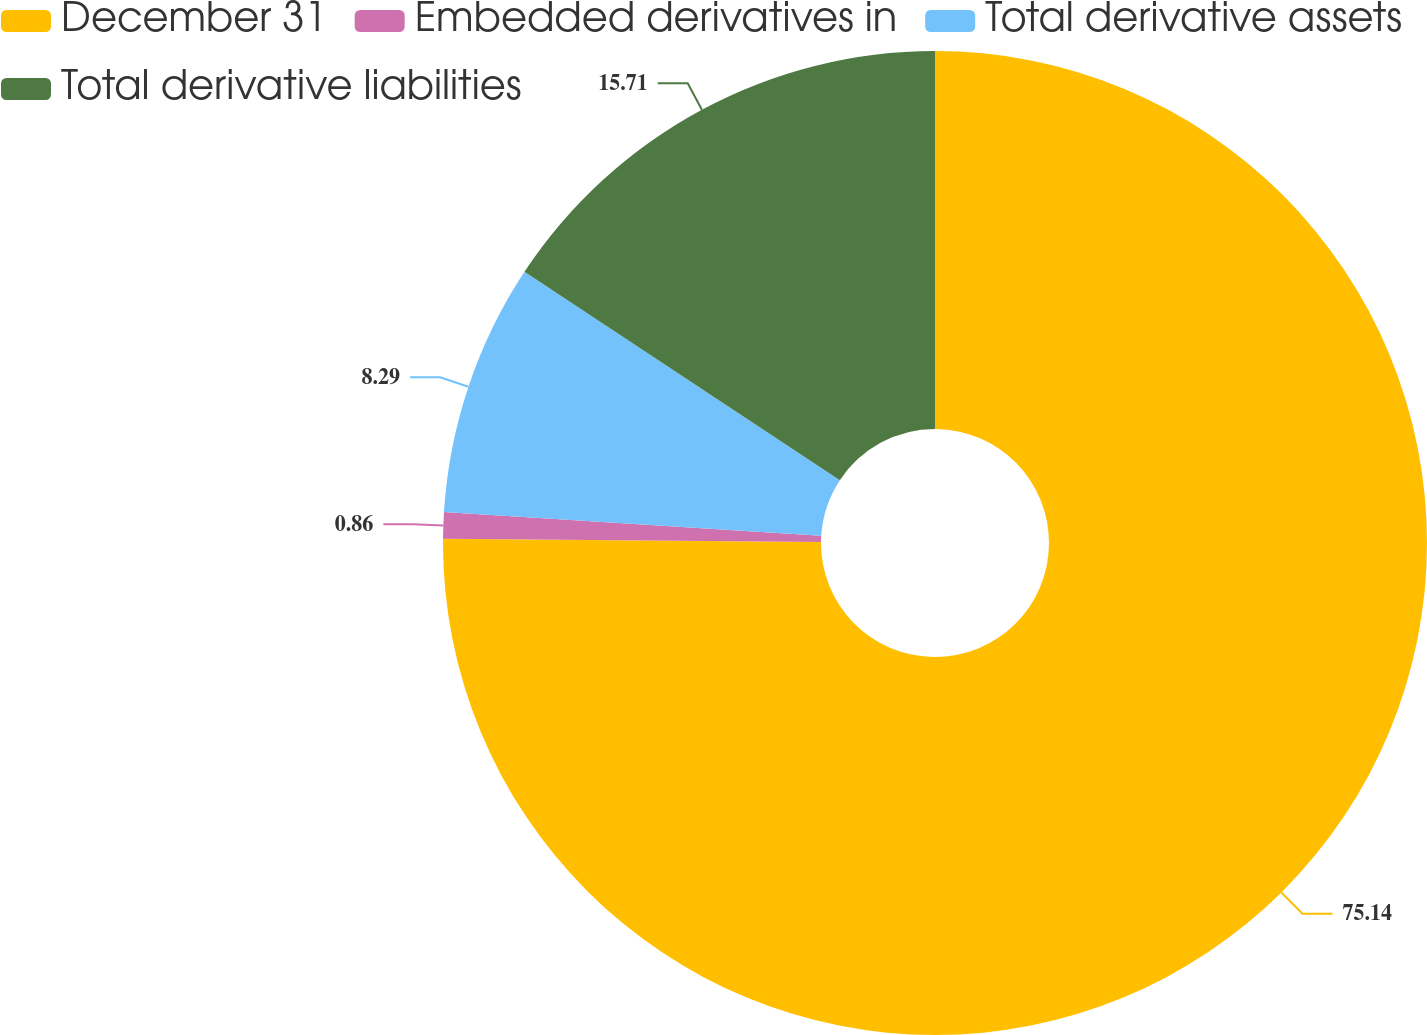Convert chart to OTSL. <chart><loc_0><loc_0><loc_500><loc_500><pie_chart><fcel>December 31<fcel>Embedded derivatives in<fcel>Total derivative assets<fcel>Total derivative liabilities<nl><fcel>75.14%<fcel>0.86%<fcel>8.29%<fcel>15.71%<nl></chart> 